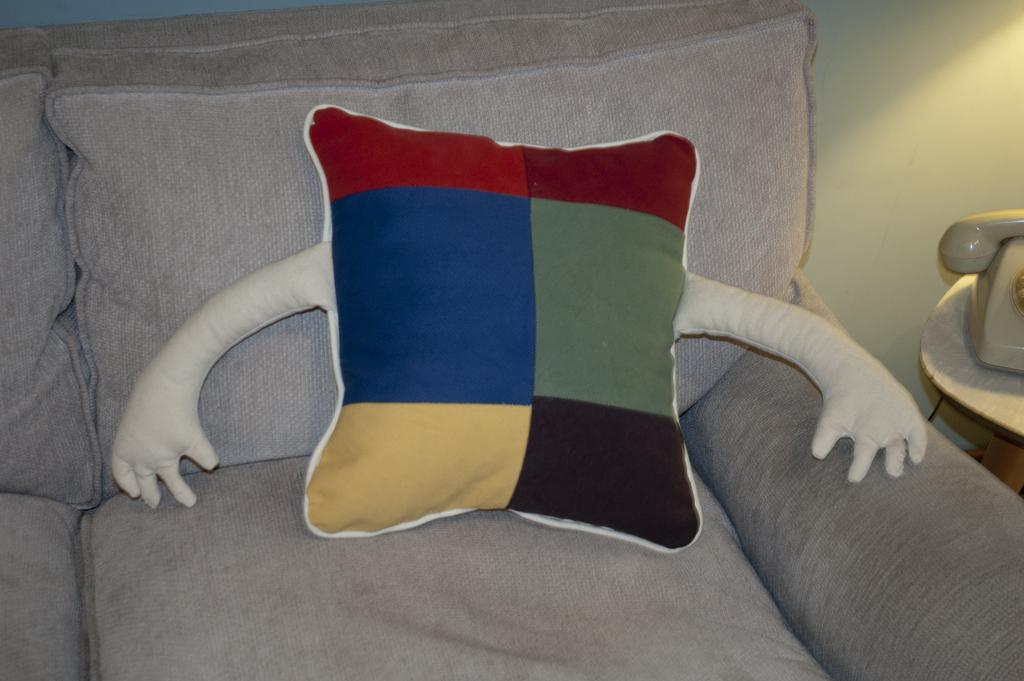What type of furniture is in the image? There is a couch in the image. What is on the couch? There is a cushion on the couch. What electronic device is visible in the image? There is a television on the right side of the image. What is at the back of the image? There is a wall at the back of the image. Can you hear an argument taking place in the image? There is no audio component to the image, so it is impossible to determine if an argument is taking place. Is there an ocean visible in the image? There is no ocean present in the image. 